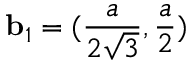Convert formula to latex. <formula><loc_0><loc_0><loc_500><loc_500>{ b } _ { 1 } = ( \frac { a } { 2 \sqrt { 3 } } , \frac { a } { 2 } )</formula> 